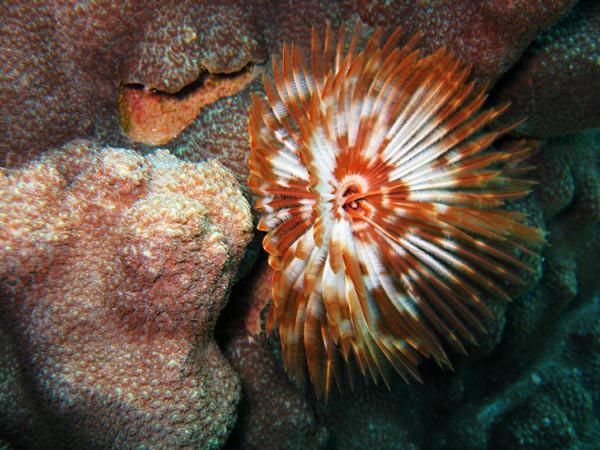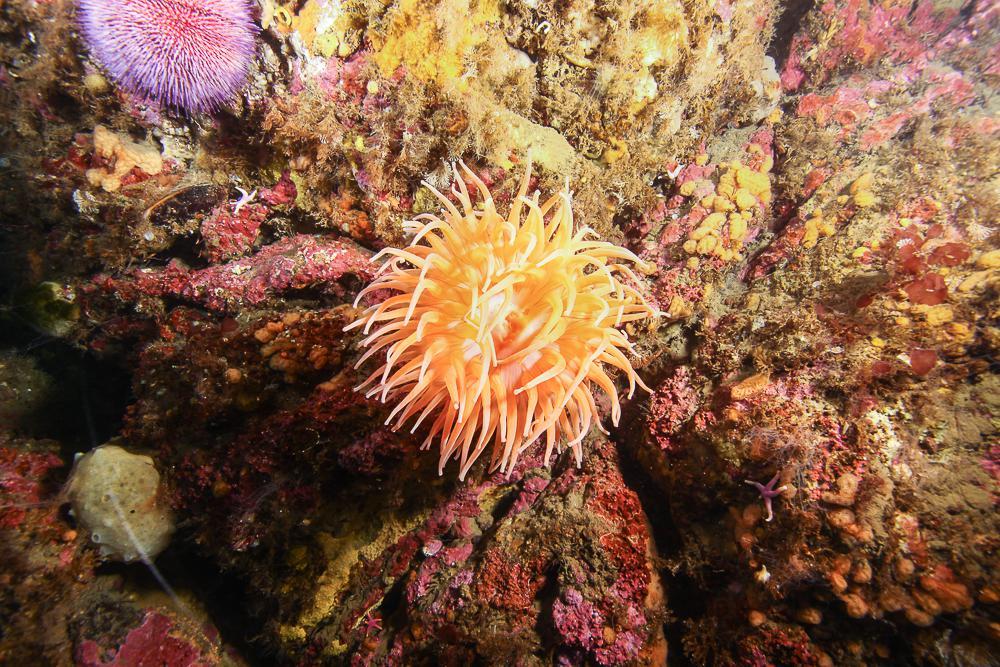The first image is the image on the left, the second image is the image on the right. Given the left and right images, does the statement "There are two white anemones." hold true? Answer yes or no. No. 